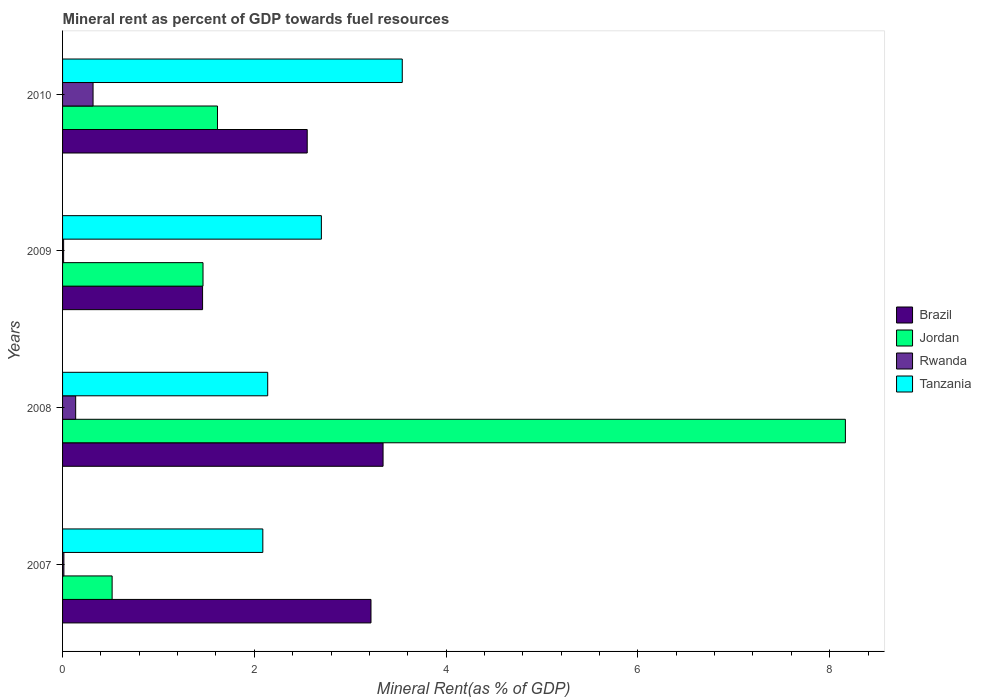How many different coloured bars are there?
Provide a succinct answer. 4. How many bars are there on the 2nd tick from the bottom?
Ensure brevity in your answer.  4. What is the label of the 1st group of bars from the top?
Your answer should be compact. 2010. What is the mineral rent in Brazil in 2010?
Your response must be concise. 2.55. Across all years, what is the maximum mineral rent in Tanzania?
Ensure brevity in your answer.  3.54. Across all years, what is the minimum mineral rent in Tanzania?
Provide a succinct answer. 2.09. In which year was the mineral rent in Jordan maximum?
Give a very brief answer. 2008. In which year was the mineral rent in Jordan minimum?
Offer a terse response. 2007. What is the total mineral rent in Jordan in the graph?
Offer a terse response. 11.76. What is the difference between the mineral rent in Tanzania in 2008 and that in 2009?
Offer a terse response. -0.56. What is the difference between the mineral rent in Brazil in 2008 and the mineral rent in Tanzania in 2007?
Ensure brevity in your answer.  1.25. What is the average mineral rent in Tanzania per year?
Make the answer very short. 2.62. In the year 2009, what is the difference between the mineral rent in Tanzania and mineral rent in Rwanda?
Offer a terse response. 2.69. What is the ratio of the mineral rent in Tanzania in 2009 to that in 2010?
Ensure brevity in your answer.  0.76. Is the difference between the mineral rent in Tanzania in 2008 and 2009 greater than the difference between the mineral rent in Rwanda in 2008 and 2009?
Your response must be concise. No. What is the difference between the highest and the second highest mineral rent in Tanzania?
Give a very brief answer. 0.84. What is the difference between the highest and the lowest mineral rent in Brazil?
Ensure brevity in your answer.  1.88. Is the sum of the mineral rent in Tanzania in 2009 and 2010 greater than the maximum mineral rent in Brazil across all years?
Your answer should be compact. Yes. Is it the case that in every year, the sum of the mineral rent in Jordan and mineral rent in Rwanda is greater than the sum of mineral rent in Tanzania and mineral rent in Brazil?
Make the answer very short. Yes. What does the 3rd bar from the top in 2008 represents?
Your answer should be compact. Jordan. What does the 3rd bar from the bottom in 2008 represents?
Provide a short and direct response. Rwanda. Is it the case that in every year, the sum of the mineral rent in Rwanda and mineral rent in Brazil is greater than the mineral rent in Tanzania?
Provide a short and direct response. No. How many bars are there?
Offer a very short reply. 16. Are all the bars in the graph horizontal?
Your answer should be compact. Yes. How many legend labels are there?
Offer a terse response. 4. How are the legend labels stacked?
Offer a very short reply. Vertical. What is the title of the graph?
Keep it short and to the point. Mineral rent as percent of GDP towards fuel resources. What is the label or title of the X-axis?
Make the answer very short. Mineral Rent(as % of GDP). What is the Mineral Rent(as % of GDP) of Brazil in 2007?
Keep it short and to the point. 3.22. What is the Mineral Rent(as % of GDP) of Jordan in 2007?
Provide a succinct answer. 0.52. What is the Mineral Rent(as % of GDP) in Rwanda in 2007?
Provide a succinct answer. 0.01. What is the Mineral Rent(as % of GDP) of Tanzania in 2007?
Offer a terse response. 2.09. What is the Mineral Rent(as % of GDP) of Brazil in 2008?
Offer a terse response. 3.34. What is the Mineral Rent(as % of GDP) of Jordan in 2008?
Offer a very short reply. 8.16. What is the Mineral Rent(as % of GDP) of Rwanda in 2008?
Offer a terse response. 0.14. What is the Mineral Rent(as % of GDP) in Tanzania in 2008?
Ensure brevity in your answer.  2.14. What is the Mineral Rent(as % of GDP) in Brazil in 2009?
Offer a very short reply. 1.46. What is the Mineral Rent(as % of GDP) of Jordan in 2009?
Your answer should be compact. 1.46. What is the Mineral Rent(as % of GDP) in Rwanda in 2009?
Provide a short and direct response. 0.01. What is the Mineral Rent(as % of GDP) in Tanzania in 2009?
Offer a very short reply. 2.7. What is the Mineral Rent(as % of GDP) of Brazil in 2010?
Your answer should be compact. 2.55. What is the Mineral Rent(as % of GDP) of Jordan in 2010?
Provide a short and direct response. 1.62. What is the Mineral Rent(as % of GDP) of Rwanda in 2010?
Ensure brevity in your answer.  0.32. What is the Mineral Rent(as % of GDP) in Tanzania in 2010?
Your response must be concise. 3.54. Across all years, what is the maximum Mineral Rent(as % of GDP) in Brazil?
Offer a terse response. 3.34. Across all years, what is the maximum Mineral Rent(as % of GDP) in Jordan?
Give a very brief answer. 8.16. Across all years, what is the maximum Mineral Rent(as % of GDP) in Rwanda?
Provide a short and direct response. 0.32. Across all years, what is the maximum Mineral Rent(as % of GDP) of Tanzania?
Provide a short and direct response. 3.54. Across all years, what is the minimum Mineral Rent(as % of GDP) in Brazil?
Provide a short and direct response. 1.46. Across all years, what is the minimum Mineral Rent(as % of GDP) of Jordan?
Provide a short and direct response. 0.52. Across all years, what is the minimum Mineral Rent(as % of GDP) of Rwanda?
Provide a succinct answer. 0.01. Across all years, what is the minimum Mineral Rent(as % of GDP) of Tanzania?
Provide a succinct answer. 2.09. What is the total Mineral Rent(as % of GDP) in Brazil in the graph?
Make the answer very short. 10.57. What is the total Mineral Rent(as % of GDP) in Jordan in the graph?
Keep it short and to the point. 11.76. What is the total Mineral Rent(as % of GDP) of Rwanda in the graph?
Make the answer very short. 0.48. What is the total Mineral Rent(as % of GDP) of Tanzania in the graph?
Provide a succinct answer. 10.47. What is the difference between the Mineral Rent(as % of GDP) of Brazil in 2007 and that in 2008?
Provide a succinct answer. -0.13. What is the difference between the Mineral Rent(as % of GDP) in Jordan in 2007 and that in 2008?
Your response must be concise. -7.65. What is the difference between the Mineral Rent(as % of GDP) of Rwanda in 2007 and that in 2008?
Offer a very short reply. -0.12. What is the difference between the Mineral Rent(as % of GDP) of Tanzania in 2007 and that in 2008?
Make the answer very short. -0.05. What is the difference between the Mineral Rent(as % of GDP) in Brazil in 2007 and that in 2009?
Your response must be concise. 1.76. What is the difference between the Mineral Rent(as % of GDP) of Jordan in 2007 and that in 2009?
Make the answer very short. -0.95. What is the difference between the Mineral Rent(as % of GDP) of Rwanda in 2007 and that in 2009?
Your response must be concise. 0. What is the difference between the Mineral Rent(as % of GDP) of Tanzania in 2007 and that in 2009?
Give a very brief answer. -0.61. What is the difference between the Mineral Rent(as % of GDP) in Brazil in 2007 and that in 2010?
Ensure brevity in your answer.  0.67. What is the difference between the Mineral Rent(as % of GDP) of Jordan in 2007 and that in 2010?
Provide a short and direct response. -1.1. What is the difference between the Mineral Rent(as % of GDP) of Rwanda in 2007 and that in 2010?
Ensure brevity in your answer.  -0.3. What is the difference between the Mineral Rent(as % of GDP) of Tanzania in 2007 and that in 2010?
Offer a very short reply. -1.45. What is the difference between the Mineral Rent(as % of GDP) in Brazil in 2008 and that in 2009?
Provide a short and direct response. 1.88. What is the difference between the Mineral Rent(as % of GDP) in Jordan in 2008 and that in 2009?
Provide a short and direct response. 6.7. What is the difference between the Mineral Rent(as % of GDP) in Rwanda in 2008 and that in 2009?
Make the answer very short. 0.13. What is the difference between the Mineral Rent(as % of GDP) in Tanzania in 2008 and that in 2009?
Ensure brevity in your answer.  -0.56. What is the difference between the Mineral Rent(as % of GDP) of Brazil in 2008 and that in 2010?
Your response must be concise. 0.79. What is the difference between the Mineral Rent(as % of GDP) of Jordan in 2008 and that in 2010?
Offer a terse response. 6.55. What is the difference between the Mineral Rent(as % of GDP) in Rwanda in 2008 and that in 2010?
Make the answer very short. -0.18. What is the difference between the Mineral Rent(as % of GDP) of Tanzania in 2008 and that in 2010?
Your answer should be very brief. -1.4. What is the difference between the Mineral Rent(as % of GDP) of Brazil in 2009 and that in 2010?
Provide a succinct answer. -1.09. What is the difference between the Mineral Rent(as % of GDP) in Jordan in 2009 and that in 2010?
Offer a terse response. -0.15. What is the difference between the Mineral Rent(as % of GDP) in Rwanda in 2009 and that in 2010?
Provide a succinct answer. -0.31. What is the difference between the Mineral Rent(as % of GDP) in Tanzania in 2009 and that in 2010?
Your response must be concise. -0.84. What is the difference between the Mineral Rent(as % of GDP) of Brazil in 2007 and the Mineral Rent(as % of GDP) of Jordan in 2008?
Your response must be concise. -4.95. What is the difference between the Mineral Rent(as % of GDP) in Brazil in 2007 and the Mineral Rent(as % of GDP) in Rwanda in 2008?
Provide a short and direct response. 3.08. What is the difference between the Mineral Rent(as % of GDP) in Brazil in 2007 and the Mineral Rent(as % of GDP) in Tanzania in 2008?
Offer a very short reply. 1.08. What is the difference between the Mineral Rent(as % of GDP) of Jordan in 2007 and the Mineral Rent(as % of GDP) of Rwanda in 2008?
Provide a succinct answer. 0.38. What is the difference between the Mineral Rent(as % of GDP) of Jordan in 2007 and the Mineral Rent(as % of GDP) of Tanzania in 2008?
Your answer should be compact. -1.62. What is the difference between the Mineral Rent(as % of GDP) of Rwanda in 2007 and the Mineral Rent(as % of GDP) of Tanzania in 2008?
Give a very brief answer. -2.13. What is the difference between the Mineral Rent(as % of GDP) of Brazil in 2007 and the Mineral Rent(as % of GDP) of Jordan in 2009?
Your response must be concise. 1.75. What is the difference between the Mineral Rent(as % of GDP) of Brazil in 2007 and the Mineral Rent(as % of GDP) of Rwanda in 2009?
Make the answer very short. 3.21. What is the difference between the Mineral Rent(as % of GDP) in Brazil in 2007 and the Mineral Rent(as % of GDP) in Tanzania in 2009?
Your answer should be compact. 0.52. What is the difference between the Mineral Rent(as % of GDP) of Jordan in 2007 and the Mineral Rent(as % of GDP) of Rwanda in 2009?
Make the answer very short. 0.51. What is the difference between the Mineral Rent(as % of GDP) of Jordan in 2007 and the Mineral Rent(as % of GDP) of Tanzania in 2009?
Keep it short and to the point. -2.18. What is the difference between the Mineral Rent(as % of GDP) in Rwanda in 2007 and the Mineral Rent(as % of GDP) in Tanzania in 2009?
Offer a terse response. -2.69. What is the difference between the Mineral Rent(as % of GDP) in Brazil in 2007 and the Mineral Rent(as % of GDP) in Jordan in 2010?
Keep it short and to the point. 1.6. What is the difference between the Mineral Rent(as % of GDP) of Brazil in 2007 and the Mineral Rent(as % of GDP) of Rwanda in 2010?
Keep it short and to the point. 2.9. What is the difference between the Mineral Rent(as % of GDP) in Brazil in 2007 and the Mineral Rent(as % of GDP) in Tanzania in 2010?
Offer a terse response. -0.33. What is the difference between the Mineral Rent(as % of GDP) of Jordan in 2007 and the Mineral Rent(as % of GDP) of Rwanda in 2010?
Provide a short and direct response. 0.2. What is the difference between the Mineral Rent(as % of GDP) of Jordan in 2007 and the Mineral Rent(as % of GDP) of Tanzania in 2010?
Make the answer very short. -3.03. What is the difference between the Mineral Rent(as % of GDP) in Rwanda in 2007 and the Mineral Rent(as % of GDP) in Tanzania in 2010?
Ensure brevity in your answer.  -3.53. What is the difference between the Mineral Rent(as % of GDP) in Brazil in 2008 and the Mineral Rent(as % of GDP) in Jordan in 2009?
Provide a short and direct response. 1.88. What is the difference between the Mineral Rent(as % of GDP) in Brazil in 2008 and the Mineral Rent(as % of GDP) in Rwanda in 2009?
Ensure brevity in your answer.  3.33. What is the difference between the Mineral Rent(as % of GDP) in Brazil in 2008 and the Mineral Rent(as % of GDP) in Tanzania in 2009?
Give a very brief answer. 0.64. What is the difference between the Mineral Rent(as % of GDP) in Jordan in 2008 and the Mineral Rent(as % of GDP) in Rwanda in 2009?
Keep it short and to the point. 8.15. What is the difference between the Mineral Rent(as % of GDP) in Jordan in 2008 and the Mineral Rent(as % of GDP) in Tanzania in 2009?
Give a very brief answer. 5.46. What is the difference between the Mineral Rent(as % of GDP) in Rwanda in 2008 and the Mineral Rent(as % of GDP) in Tanzania in 2009?
Make the answer very short. -2.56. What is the difference between the Mineral Rent(as % of GDP) of Brazil in 2008 and the Mineral Rent(as % of GDP) of Jordan in 2010?
Ensure brevity in your answer.  1.73. What is the difference between the Mineral Rent(as % of GDP) in Brazil in 2008 and the Mineral Rent(as % of GDP) in Rwanda in 2010?
Ensure brevity in your answer.  3.02. What is the difference between the Mineral Rent(as % of GDP) of Brazil in 2008 and the Mineral Rent(as % of GDP) of Tanzania in 2010?
Your answer should be very brief. -0.2. What is the difference between the Mineral Rent(as % of GDP) of Jordan in 2008 and the Mineral Rent(as % of GDP) of Rwanda in 2010?
Offer a very short reply. 7.85. What is the difference between the Mineral Rent(as % of GDP) in Jordan in 2008 and the Mineral Rent(as % of GDP) in Tanzania in 2010?
Your answer should be very brief. 4.62. What is the difference between the Mineral Rent(as % of GDP) in Rwanda in 2008 and the Mineral Rent(as % of GDP) in Tanzania in 2010?
Your answer should be compact. -3.41. What is the difference between the Mineral Rent(as % of GDP) in Brazil in 2009 and the Mineral Rent(as % of GDP) in Jordan in 2010?
Offer a terse response. -0.16. What is the difference between the Mineral Rent(as % of GDP) of Brazil in 2009 and the Mineral Rent(as % of GDP) of Rwanda in 2010?
Provide a short and direct response. 1.14. What is the difference between the Mineral Rent(as % of GDP) of Brazil in 2009 and the Mineral Rent(as % of GDP) of Tanzania in 2010?
Keep it short and to the point. -2.08. What is the difference between the Mineral Rent(as % of GDP) in Jordan in 2009 and the Mineral Rent(as % of GDP) in Rwanda in 2010?
Offer a very short reply. 1.15. What is the difference between the Mineral Rent(as % of GDP) in Jordan in 2009 and the Mineral Rent(as % of GDP) in Tanzania in 2010?
Your response must be concise. -2.08. What is the difference between the Mineral Rent(as % of GDP) of Rwanda in 2009 and the Mineral Rent(as % of GDP) of Tanzania in 2010?
Provide a succinct answer. -3.53. What is the average Mineral Rent(as % of GDP) in Brazil per year?
Provide a succinct answer. 2.64. What is the average Mineral Rent(as % of GDP) in Jordan per year?
Offer a very short reply. 2.94. What is the average Mineral Rent(as % of GDP) in Rwanda per year?
Provide a short and direct response. 0.12. What is the average Mineral Rent(as % of GDP) in Tanzania per year?
Offer a very short reply. 2.62. In the year 2007, what is the difference between the Mineral Rent(as % of GDP) of Brazil and Mineral Rent(as % of GDP) of Jordan?
Your answer should be compact. 2.7. In the year 2007, what is the difference between the Mineral Rent(as % of GDP) of Brazil and Mineral Rent(as % of GDP) of Rwanda?
Offer a terse response. 3.2. In the year 2007, what is the difference between the Mineral Rent(as % of GDP) of Brazil and Mineral Rent(as % of GDP) of Tanzania?
Offer a terse response. 1.13. In the year 2007, what is the difference between the Mineral Rent(as % of GDP) in Jordan and Mineral Rent(as % of GDP) in Rwanda?
Offer a terse response. 0.5. In the year 2007, what is the difference between the Mineral Rent(as % of GDP) of Jordan and Mineral Rent(as % of GDP) of Tanzania?
Keep it short and to the point. -1.57. In the year 2007, what is the difference between the Mineral Rent(as % of GDP) of Rwanda and Mineral Rent(as % of GDP) of Tanzania?
Your response must be concise. -2.07. In the year 2008, what is the difference between the Mineral Rent(as % of GDP) in Brazil and Mineral Rent(as % of GDP) in Jordan?
Provide a short and direct response. -4.82. In the year 2008, what is the difference between the Mineral Rent(as % of GDP) in Brazil and Mineral Rent(as % of GDP) in Rwanda?
Your answer should be compact. 3.21. In the year 2008, what is the difference between the Mineral Rent(as % of GDP) in Brazil and Mineral Rent(as % of GDP) in Tanzania?
Your answer should be very brief. 1.2. In the year 2008, what is the difference between the Mineral Rent(as % of GDP) in Jordan and Mineral Rent(as % of GDP) in Rwanda?
Keep it short and to the point. 8.03. In the year 2008, what is the difference between the Mineral Rent(as % of GDP) in Jordan and Mineral Rent(as % of GDP) in Tanzania?
Keep it short and to the point. 6.02. In the year 2008, what is the difference between the Mineral Rent(as % of GDP) in Rwanda and Mineral Rent(as % of GDP) in Tanzania?
Offer a terse response. -2. In the year 2009, what is the difference between the Mineral Rent(as % of GDP) of Brazil and Mineral Rent(as % of GDP) of Jordan?
Offer a very short reply. -0. In the year 2009, what is the difference between the Mineral Rent(as % of GDP) of Brazil and Mineral Rent(as % of GDP) of Rwanda?
Offer a terse response. 1.45. In the year 2009, what is the difference between the Mineral Rent(as % of GDP) of Brazil and Mineral Rent(as % of GDP) of Tanzania?
Give a very brief answer. -1.24. In the year 2009, what is the difference between the Mineral Rent(as % of GDP) of Jordan and Mineral Rent(as % of GDP) of Rwanda?
Your answer should be very brief. 1.45. In the year 2009, what is the difference between the Mineral Rent(as % of GDP) of Jordan and Mineral Rent(as % of GDP) of Tanzania?
Your answer should be compact. -1.23. In the year 2009, what is the difference between the Mineral Rent(as % of GDP) in Rwanda and Mineral Rent(as % of GDP) in Tanzania?
Provide a succinct answer. -2.69. In the year 2010, what is the difference between the Mineral Rent(as % of GDP) of Brazil and Mineral Rent(as % of GDP) of Jordan?
Keep it short and to the point. 0.94. In the year 2010, what is the difference between the Mineral Rent(as % of GDP) in Brazil and Mineral Rent(as % of GDP) in Rwanda?
Your answer should be very brief. 2.23. In the year 2010, what is the difference between the Mineral Rent(as % of GDP) in Brazil and Mineral Rent(as % of GDP) in Tanzania?
Make the answer very short. -0.99. In the year 2010, what is the difference between the Mineral Rent(as % of GDP) of Jordan and Mineral Rent(as % of GDP) of Rwanda?
Your answer should be compact. 1.3. In the year 2010, what is the difference between the Mineral Rent(as % of GDP) in Jordan and Mineral Rent(as % of GDP) in Tanzania?
Ensure brevity in your answer.  -1.93. In the year 2010, what is the difference between the Mineral Rent(as % of GDP) in Rwanda and Mineral Rent(as % of GDP) in Tanzania?
Ensure brevity in your answer.  -3.22. What is the ratio of the Mineral Rent(as % of GDP) of Brazil in 2007 to that in 2008?
Provide a short and direct response. 0.96. What is the ratio of the Mineral Rent(as % of GDP) in Jordan in 2007 to that in 2008?
Your answer should be compact. 0.06. What is the ratio of the Mineral Rent(as % of GDP) of Rwanda in 2007 to that in 2008?
Make the answer very short. 0.1. What is the ratio of the Mineral Rent(as % of GDP) in Tanzania in 2007 to that in 2008?
Offer a very short reply. 0.98. What is the ratio of the Mineral Rent(as % of GDP) in Brazil in 2007 to that in 2009?
Provide a succinct answer. 2.2. What is the ratio of the Mineral Rent(as % of GDP) of Jordan in 2007 to that in 2009?
Provide a short and direct response. 0.35. What is the ratio of the Mineral Rent(as % of GDP) of Rwanda in 2007 to that in 2009?
Your response must be concise. 1.26. What is the ratio of the Mineral Rent(as % of GDP) in Tanzania in 2007 to that in 2009?
Offer a terse response. 0.77. What is the ratio of the Mineral Rent(as % of GDP) in Brazil in 2007 to that in 2010?
Ensure brevity in your answer.  1.26. What is the ratio of the Mineral Rent(as % of GDP) of Jordan in 2007 to that in 2010?
Ensure brevity in your answer.  0.32. What is the ratio of the Mineral Rent(as % of GDP) of Rwanda in 2007 to that in 2010?
Provide a short and direct response. 0.04. What is the ratio of the Mineral Rent(as % of GDP) of Tanzania in 2007 to that in 2010?
Provide a short and direct response. 0.59. What is the ratio of the Mineral Rent(as % of GDP) of Brazil in 2008 to that in 2009?
Give a very brief answer. 2.29. What is the ratio of the Mineral Rent(as % of GDP) in Jordan in 2008 to that in 2009?
Offer a terse response. 5.57. What is the ratio of the Mineral Rent(as % of GDP) in Rwanda in 2008 to that in 2009?
Provide a short and direct response. 12.42. What is the ratio of the Mineral Rent(as % of GDP) of Tanzania in 2008 to that in 2009?
Your answer should be very brief. 0.79. What is the ratio of the Mineral Rent(as % of GDP) of Brazil in 2008 to that in 2010?
Keep it short and to the point. 1.31. What is the ratio of the Mineral Rent(as % of GDP) of Jordan in 2008 to that in 2010?
Provide a succinct answer. 5.05. What is the ratio of the Mineral Rent(as % of GDP) of Rwanda in 2008 to that in 2010?
Make the answer very short. 0.43. What is the ratio of the Mineral Rent(as % of GDP) of Tanzania in 2008 to that in 2010?
Your response must be concise. 0.6. What is the ratio of the Mineral Rent(as % of GDP) of Brazil in 2009 to that in 2010?
Your answer should be very brief. 0.57. What is the ratio of the Mineral Rent(as % of GDP) of Jordan in 2009 to that in 2010?
Provide a succinct answer. 0.91. What is the ratio of the Mineral Rent(as % of GDP) in Rwanda in 2009 to that in 2010?
Provide a short and direct response. 0.03. What is the ratio of the Mineral Rent(as % of GDP) of Tanzania in 2009 to that in 2010?
Provide a short and direct response. 0.76. What is the difference between the highest and the second highest Mineral Rent(as % of GDP) in Brazil?
Keep it short and to the point. 0.13. What is the difference between the highest and the second highest Mineral Rent(as % of GDP) of Jordan?
Keep it short and to the point. 6.55. What is the difference between the highest and the second highest Mineral Rent(as % of GDP) of Rwanda?
Provide a succinct answer. 0.18. What is the difference between the highest and the second highest Mineral Rent(as % of GDP) in Tanzania?
Your answer should be compact. 0.84. What is the difference between the highest and the lowest Mineral Rent(as % of GDP) of Brazil?
Your answer should be compact. 1.88. What is the difference between the highest and the lowest Mineral Rent(as % of GDP) of Jordan?
Ensure brevity in your answer.  7.65. What is the difference between the highest and the lowest Mineral Rent(as % of GDP) of Rwanda?
Offer a terse response. 0.31. What is the difference between the highest and the lowest Mineral Rent(as % of GDP) in Tanzania?
Provide a succinct answer. 1.45. 